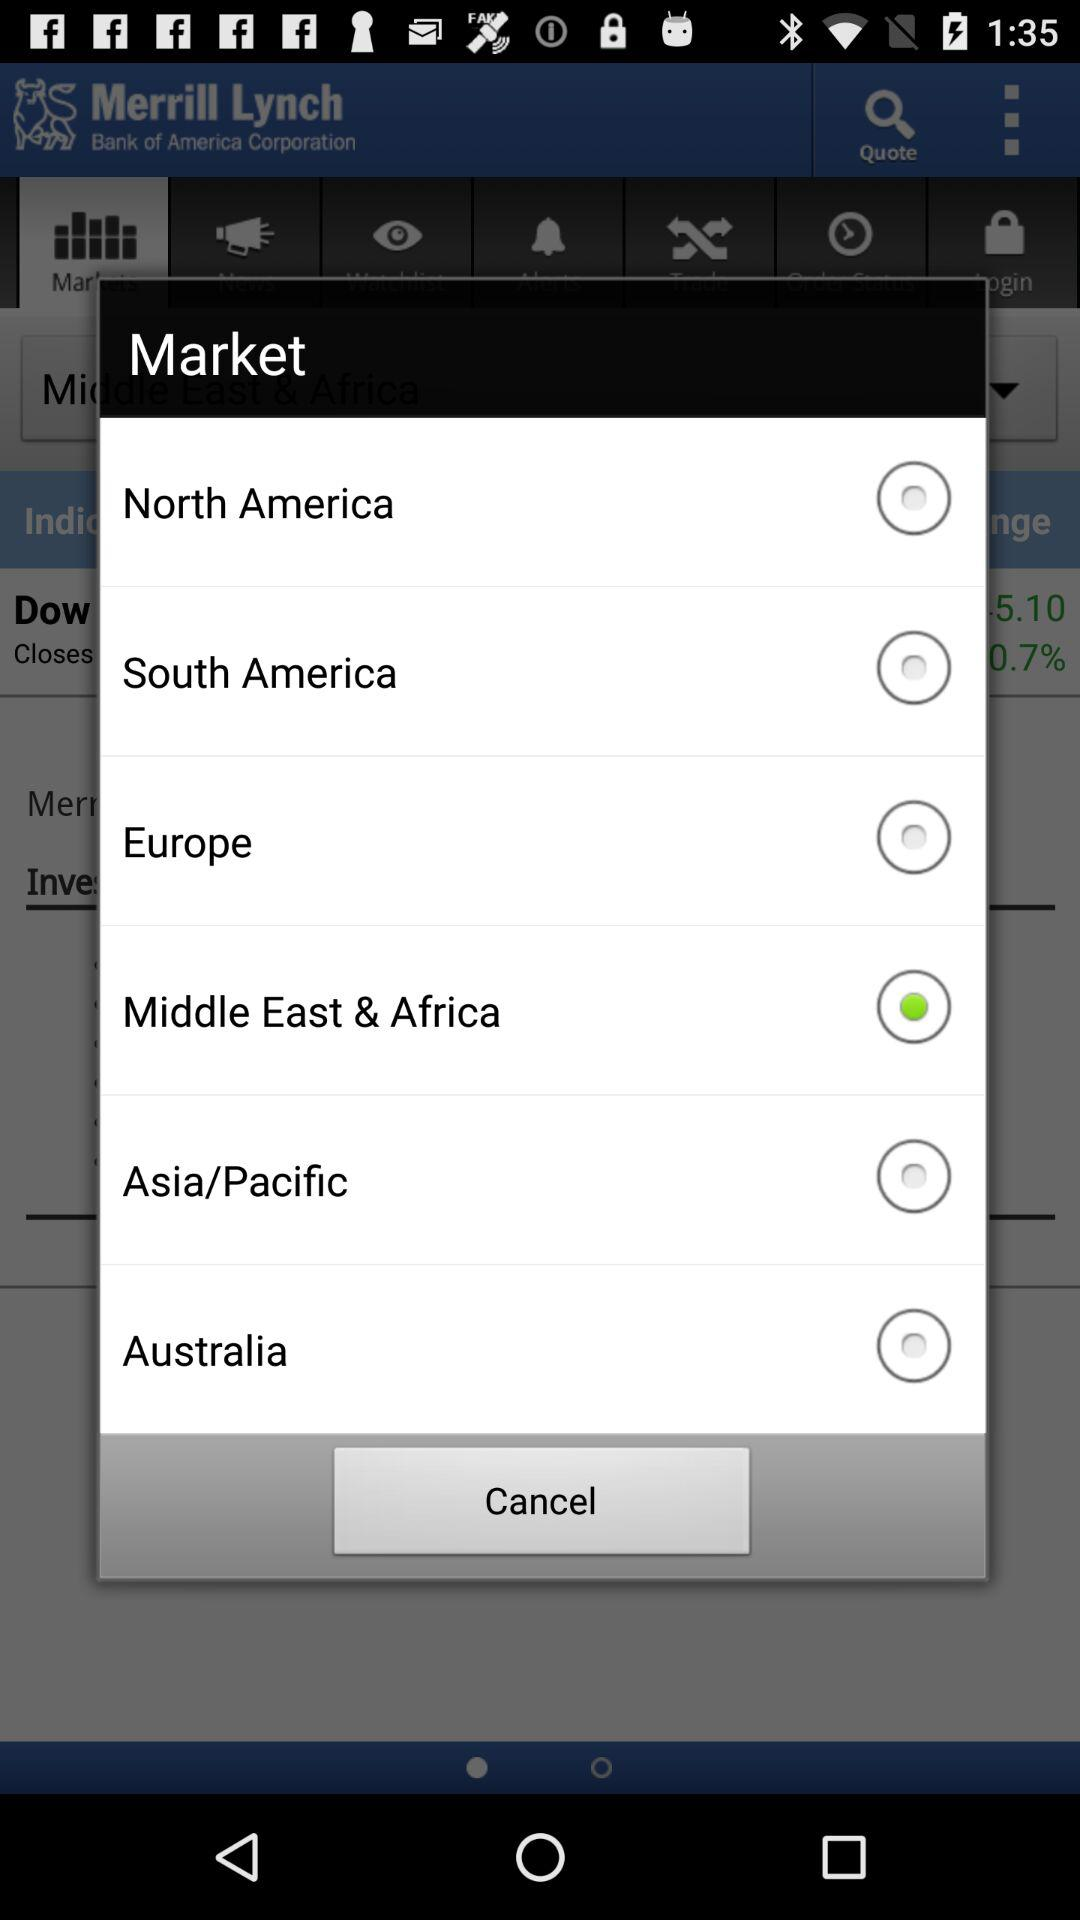What are the selected market? The selected market is Middle East & Africa. 